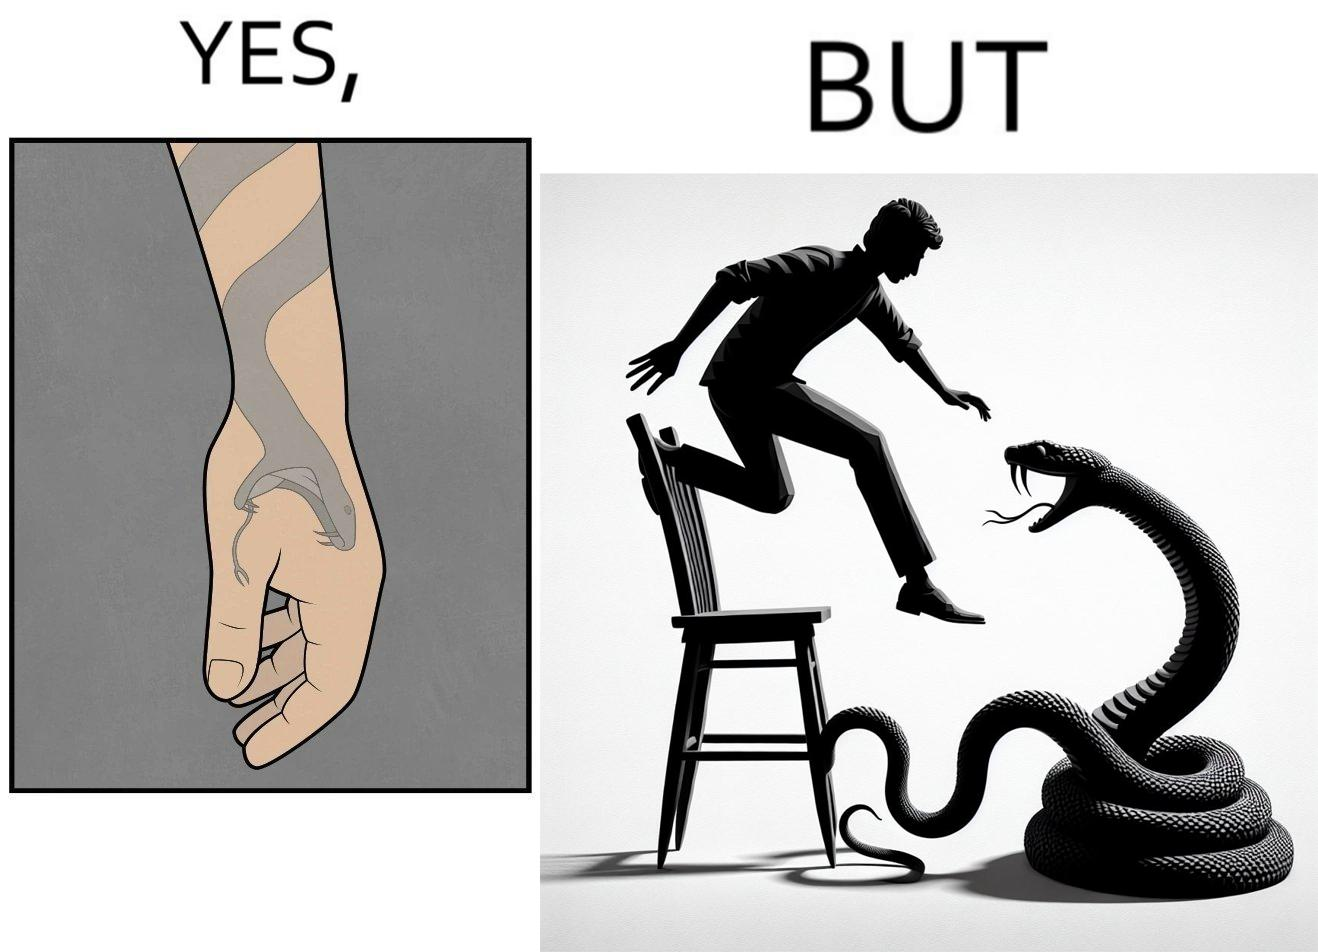Describe what you see in the left and right parts of this image. In the left part of the image: a tattoo of a snake with its mouth wide open on someone's hand In the right part of the image: a person standing on a chair trying save himself from the attack of snake and the snake is probably trying to climb up the chair 